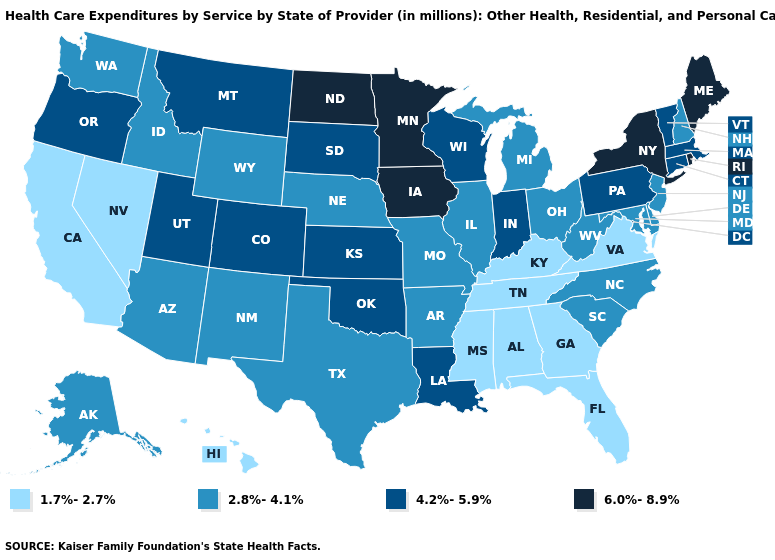Does Nevada have the highest value in the USA?
Short answer required. No. Among the states that border Texas , which have the highest value?
Be succinct. Louisiana, Oklahoma. Does North Dakota have the highest value in the USA?
Keep it brief. Yes. What is the lowest value in the USA?
Quick response, please. 1.7%-2.7%. What is the lowest value in the USA?
Short answer required. 1.7%-2.7%. Name the states that have a value in the range 4.2%-5.9%?
Quick response, please. Colorado, Connecticut, Indiana, Kansas, Louisiana, Massachusetts, Montana, Oklahoma, Oregon, Pennsylvania, South Dakota, Utah, Vermont, Wisconsin. Which states hav the highest value in the South?
Short answer required. Louisiana, Oklahoma. What is the value of Nebraska?
Concise answer only. 2.8%-4.1%. Name the states that have a value in the range 6.0%-8.9%?
Be succinct. Iowa, Maine, Minnesota, New York, North Dakota, Rhode Island. What is the highest value in states that border Montana?
Answer briefly. 6.0%-8.9%. Among the states that border Arizona , which have the highest value?
Quick response, please. Colorado, Utah. Name the states that have a value in the range 4.2%-5.9%?
Answer briefly. Colorado, Connecticut, Indiana, Kansas, Louisiana, Massachusetts, Montana, Oklahoma, Oregon, Pennsylvania, South Dakota, Utah, Vermont, Wisconsin. What is the lowest value in states that border Oregon?
Write a very short answer. 1.7%-2.7%. Which states hav the highest value in the South?
Give a very brief answer. Louisiana, Oklahoma. Name the states that have a value in the range 4.2%-5.9%?
Write a very short answer. Colorado, Connecticut, Indiana, Kansas, Louisiana, Massachusetts, Montana, Oklahoma, Oregon, Pennsylvania, South Dakota, Utah, Vermont, Wisconsin. 